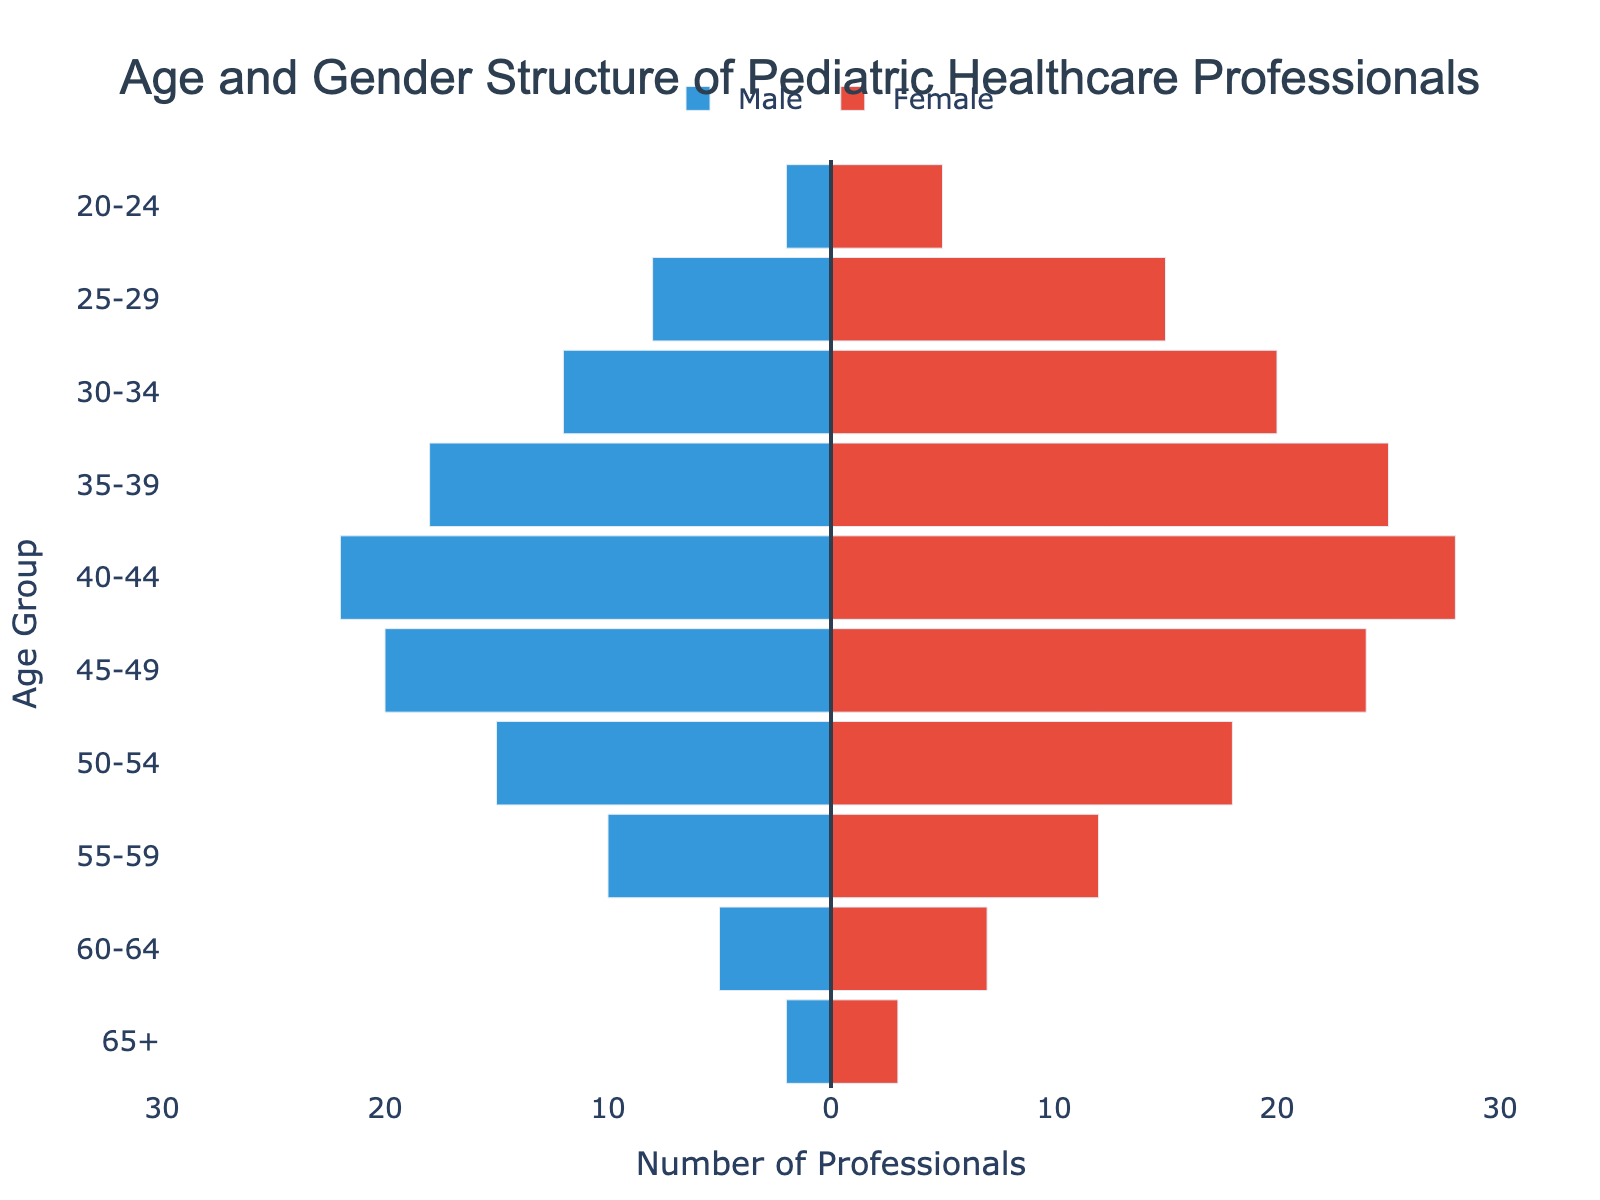What is the title of the figure? The title is located at the top of the figure and often provides a summary of what the figure represents. In this case, it indicates the content concerning age and gender structure.
Answer: Age and Gender Structure of Pediatric Healthcare Professionals What does the x-axis represent? The x-axis is labeled with a title and shows the range and units of measurement. Here, it indicates the number of professionals, ranging from -30 to 30.
Answer: Number of Professionals How many male pediatric healthcare professionals are there in the 45-49 age group? The male professionals column has negative values on the x-axis. For the 45-49 age group, the bar extends to -20, indicating there are 20 male professionals.
Answer: 20 How many female pediatric healthcare professionals are in the 25-29 age group? The female professionals column has positive values on the x-axis. For the 25-29 age group, the bar extends to 15, indicating there are 15 female professionals.
Answer: 15 Which age group has the highest number of male pediatric healthcare professionals? By comparing all the negative bars for each age group, the 40-44 age group has the longest bar extending to -22.
Answer: 40-44 Compare the number of male and female pediatric healthcare professionals in the 35-39 age group. For the 35-39 age group, the male bar extends to -18, and the female bar extends to 25. Visual comparison shows that there are more females than males.
Answer: There are more females than males What is the total number of pediatric healthcare professionals in the 50-54 age group? Adding the absolute value of male and female quantities from the bars, 15 (males) + 18 (females) = 33.
Answer: 33 Which age group has fewer female pediatric healthcare professionals, 20-24 or 60-64? By looking at the positive bars for these age groups, the 20-24 group has 5, and the 60-64 group has 7. Thus, 20-24 has fewer.
Answer: 20-24 Is there an age group where the number of male and female pediatric healthcare professionals is equal? By comparing the length of male and female bars for all age groups, there is no age group where the values are equal.
Answer: No 